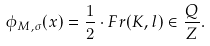Convert formula to latex. <formula><loc_0><loc_0><loc_500><loc_500>\phi _ { M , \sigma } ( x ) = \frac { 1 } { 2 } \cdot F r ( K , l ) \in \frac { Q } { Z } .</formula> 